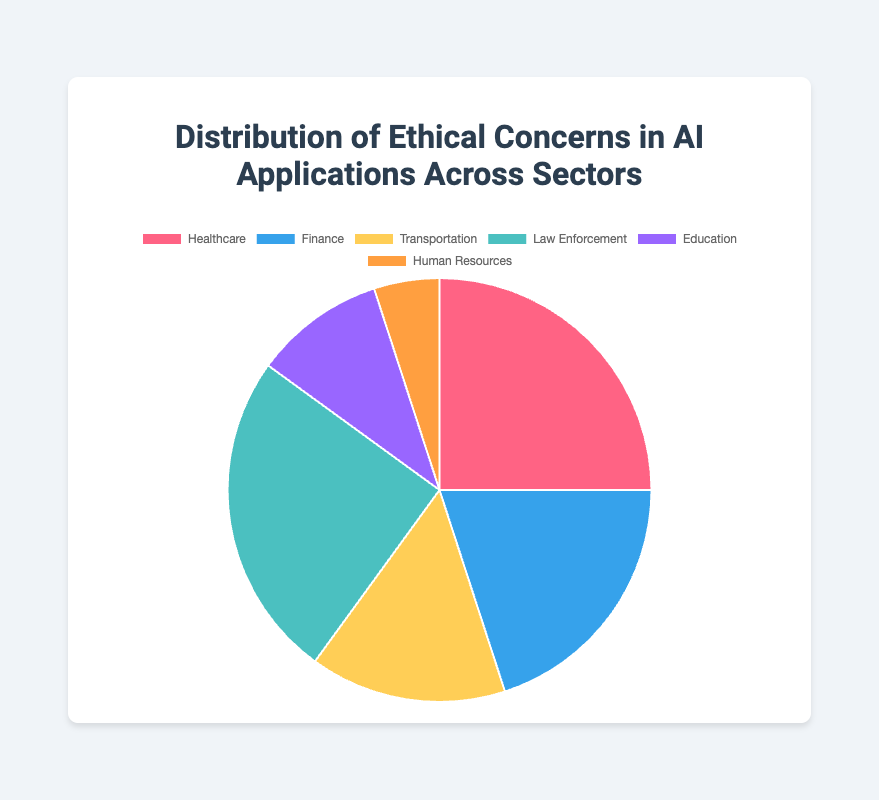Which sector has the highest ethical concerns in AI applications? Visual inspection reveals that both the Healthcare and Law Enforcement sectors have the largest segments in the pie chart, indicating the highest concerns. Each has a data point of 25.
Answer: Healthcare and Law Enforcement Which sector has the smallest percentage of ethical concerns? The sector with the smallest segment in the pie chart is Human Resources, which has a data point of 5.
Answer: Human Resources What is the total percentage of ethical concerns for Healthcare and Law Enforcement combined? The data points for Healthcare and Law Enforcement are 25 each. Adding them gives 25 + 25 = 50. Since the total sum of data points is 100, the combined percentage is (50/100) * 100 = 50%.
Answer: 50% How do ethical concerns in the Finance sector compare to those in the Transportation sector? The data point for the Finance sector is 20, while that for the Transportation sector is 15. By comparing these values, 20 is greater than 15.
Answer: Finance has more concerns What percentage of ethical concerns is attributed to the Education sector? The data point for Education is 10. Since the total sum of all sectors is 100, the percentage for Education is (10/100) * 100 = 10%.
Answer: 10% What is the difference in ethical concerns between the Healthcare and Human Resources sectors? The data point for Healthcare is 25 and for Human Resources is 5. The difference is 25 - 5 = 20.
Answer: 20 What is the combined percentage of ethical concerns in the Finance, Transportation, and Education sectors? The data points for Finance, Transportation, and Education are 20, 15, and 10 respectively. Adding these gives 20 + 15 + 10 = 45. The combined percentage is (45/100) * 100 = 45%.
Answer: 45% Which sector has a higher percentage of ethical concerns: Education or Human Resources? The Education sector has a data point of 10, whereas Human Resources has a data point of 5. Comparing these, 10 is greater than 5.
Answer: Education Based on the pie chart, what is the average percentage of ethical concerns across all sectors? The total percentage across all sectors is 100. There are 6 sectors in total. The average is 100 / 6 ≈ 16.67%.
Answer: Approximately 16.67% If ethical concerns in the Transportation sector were to double, what would be the new percentage for this sector? The current data point for Transportation is 15. Doubling it gives 15 * 2 = 30. The new total data point sum would be 100 + 15 = 115. The new percentage for Transportation would be (30/115) * 100 ≈ 26.09%.
Answer: Approximately 26.09% 